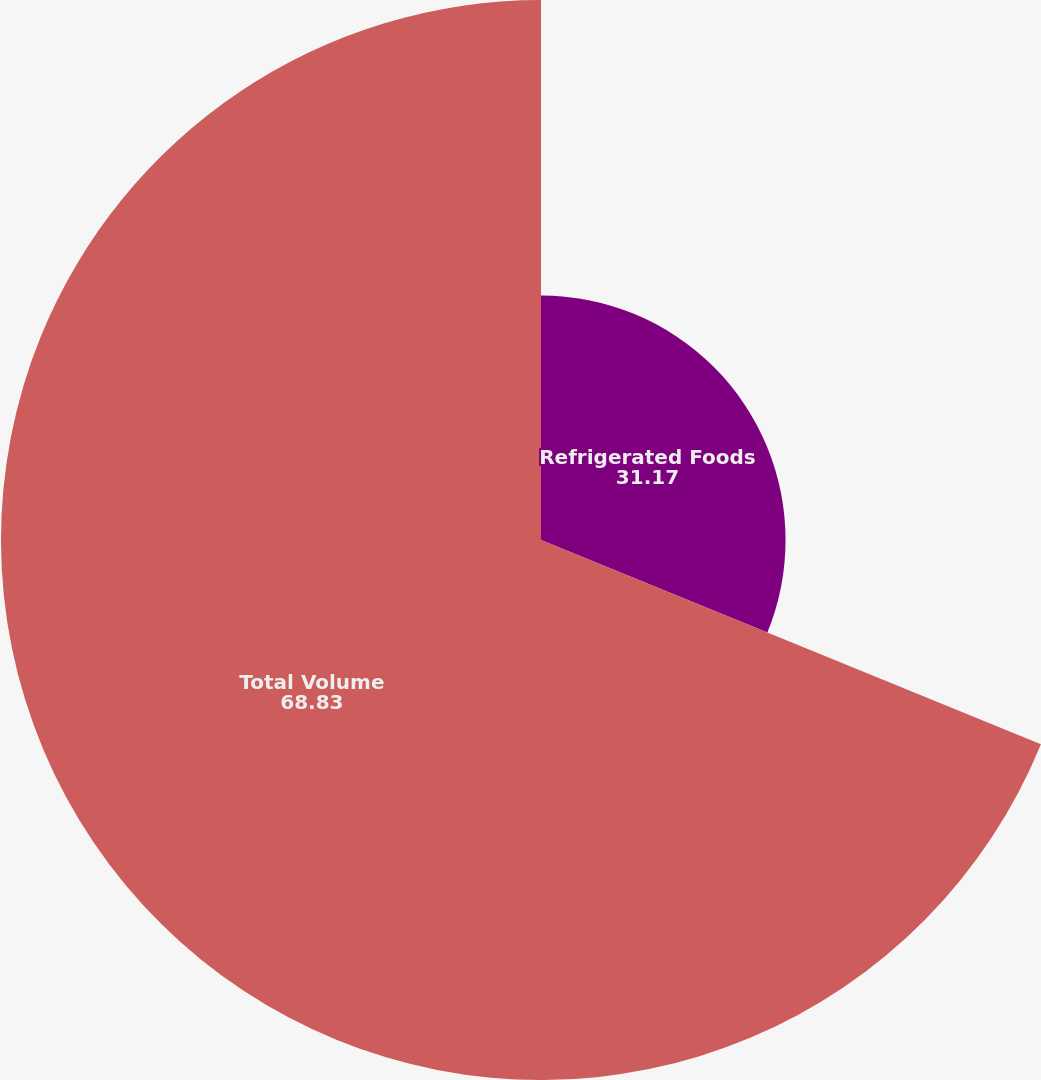Convert chart. <chart><loc_0><loc_0><loc_500><loc_500><pie_chart><fcel>Refrigerated Foods<fcel>Total Volume<nl><fcel>31.17%<fcel>68.83%<nl></chart> 